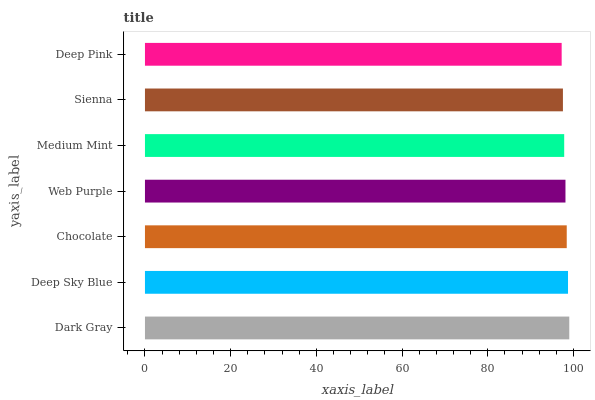Is Deep Pink the minimum?
Answer yes or no. Yes. Is Dark Gray the maximum?
Answer yes or no. Yes. Is Deep Sky Blue the minimum?
Answer yes or no. No. Is Deep Sky Blue the maximum?
Answer yes or no. No. Is Dark Gray greater than Deep Sky Blue?
Answer yes or no. Yes. Is Deep Sky Blue less than Dark Gray?
Answer yes or no. Yes. Is Deep Sky Blue greater than Dark Gray?
Answer yes or no. No. Is Dark Gray less than Deep Sky Blue?
Answer yes or no. No. Is Web Purple the high median?
Answer yes or no. Yes. Is Web Purple the low median?
Answer yes or no. Yes. Is Deep Pink the high median?
Answer yes or no. No. Is Sienna the low median?
Answer yes or no. No. 